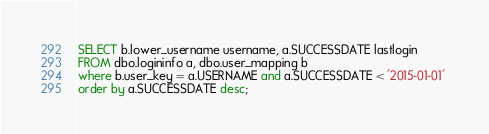<code> <loc_0><loc_0><loc_500><loc_500><_SQL_>SELECT b.lower_username username, a.SUCCESSDATE lastlogin 
FROM dbo.logininfo a, dbo.user_mapping b 
where b.user_key = a.USERNAME and a.SUCCESSDATE < '2015-01-01' 
order by a.SUCCESSDATE desc; 
</code> 